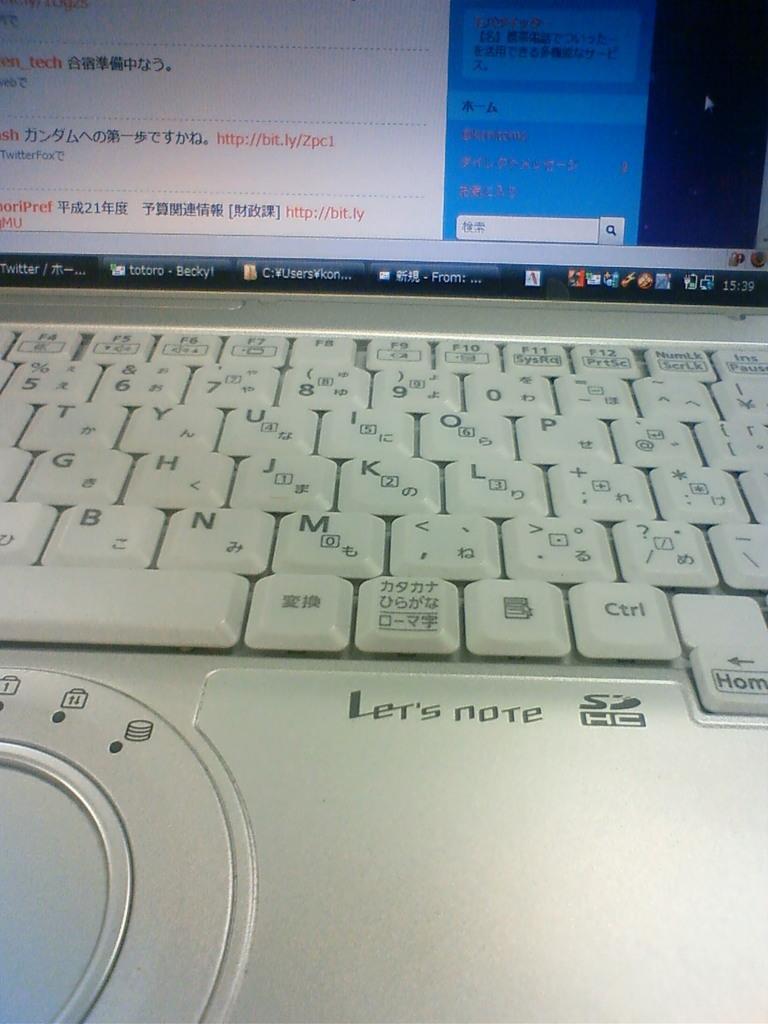In one or two sentences, can you explain what this image depicts? In this picture we can see a laptop which is truncated. 